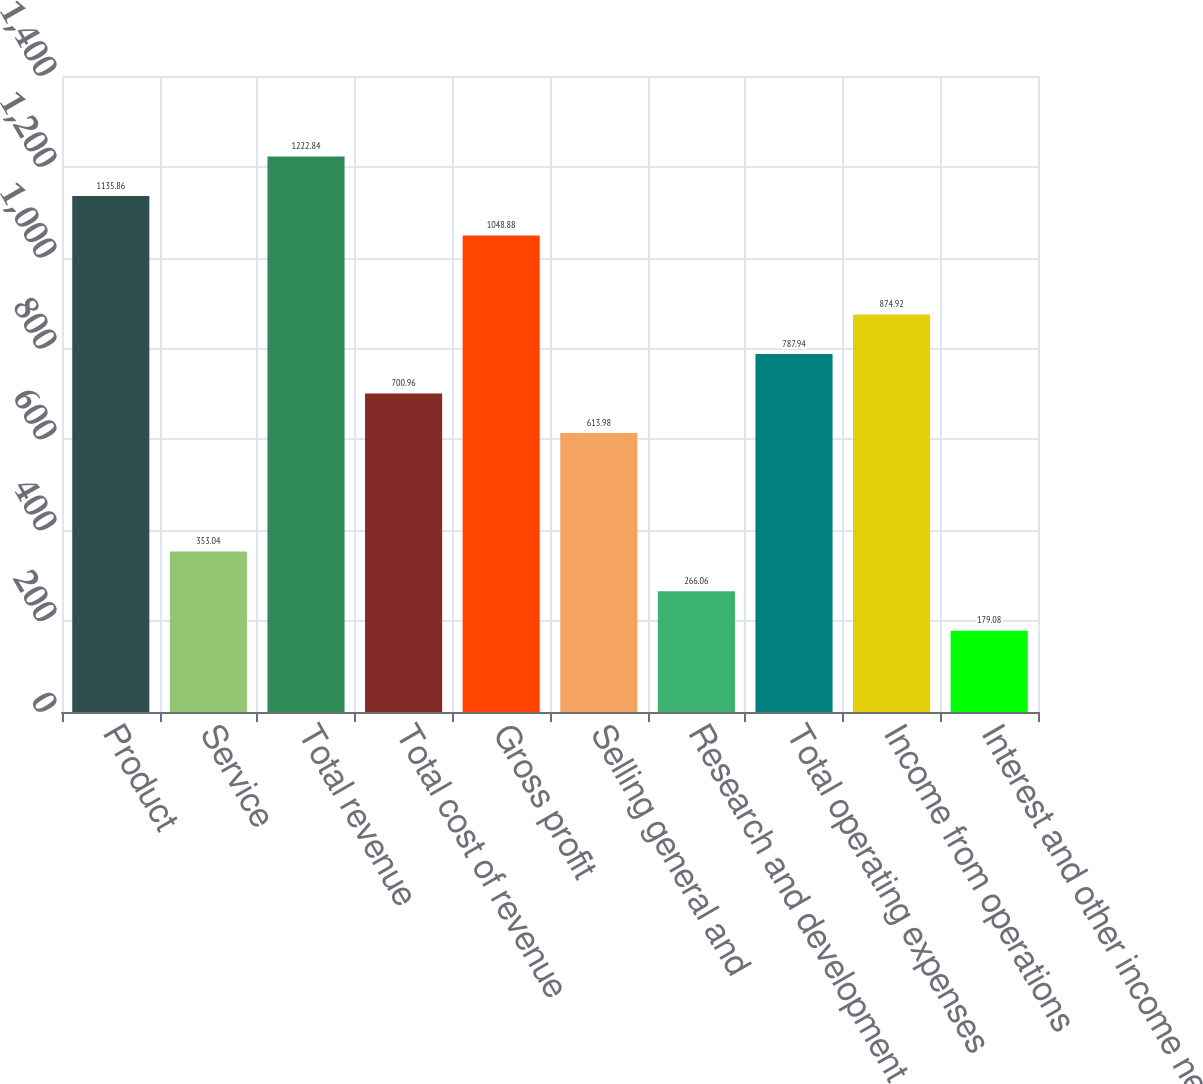<chart> <loc_0><loc_0><loc_500><loc_500><bar_chart><fcel>Product<fcel>Service<fcel>Total revenue<fcel>Total cost of revenue<fcel>Gross profit<fcel>Selling general and<fcel>Research and development<fcel>Total operating expenses<fcel>Income from operations<fcel>Interest and other income net<nl><fcel>1135.86<fcel>353.04<fcel>1222.84<fcel>700.96<fcel>1048.88<fcel>613.98<fcel>266.06<fcel>787.94<fcel>874.92<fcel>179.08<nl></chart> 